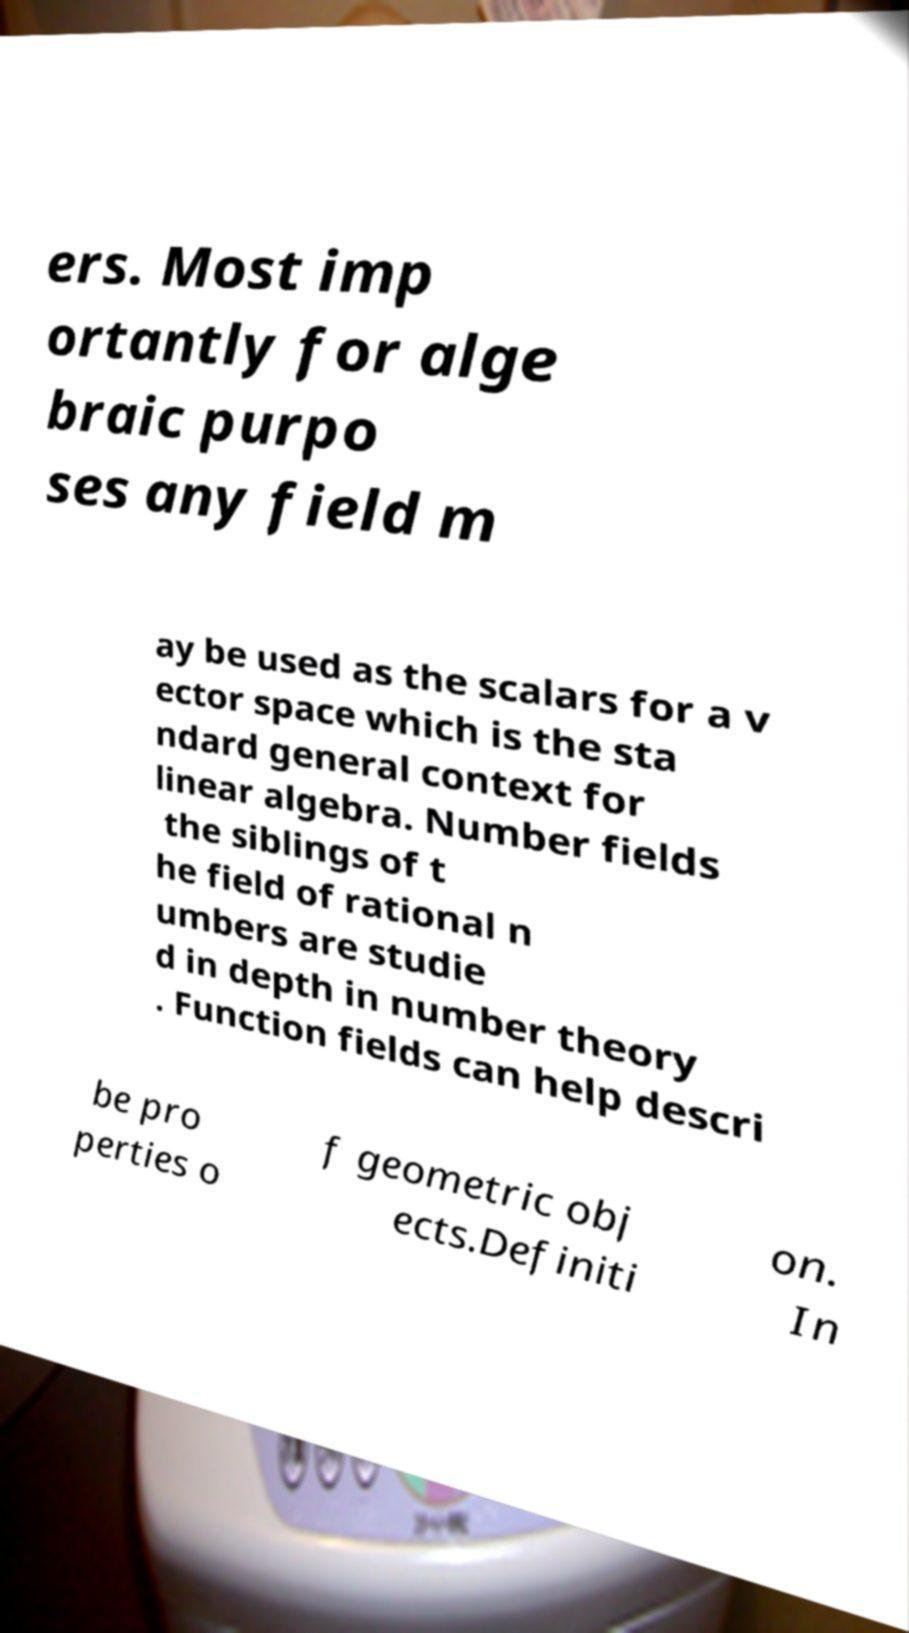Please identify and transcribe the text found in this image. ers. Most imp ortantly for alge braic purpo ses any field m ay be used as the scalars for a v ector space which is the sta ndard general context for linear algebra. Number fields the siblings of t he field of rational n umbers are studie d in depth in number theory . Function fields can help descri be pro perties o f geometric obj ects.Definiti on. In 